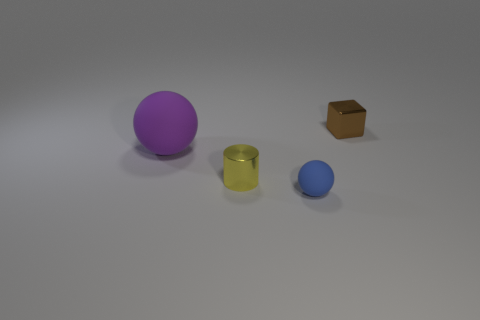Subtract all gray spheres. Subtract all purple cubes. How many spheres are left? 2 Add 1 small matte spheres. How many objects exist? 5 Subtract all blocks. How many objects are left? 3 Add 3 small brown objects. How many small brown objects exist? 4 Subtract 0 gray cylinders. How many objects are left? 4 Subtract all large red cubes. Subtract all large purple matte balls. How many objects are left? 3 Add 1 small brown things. How many small brown things are left? 2 